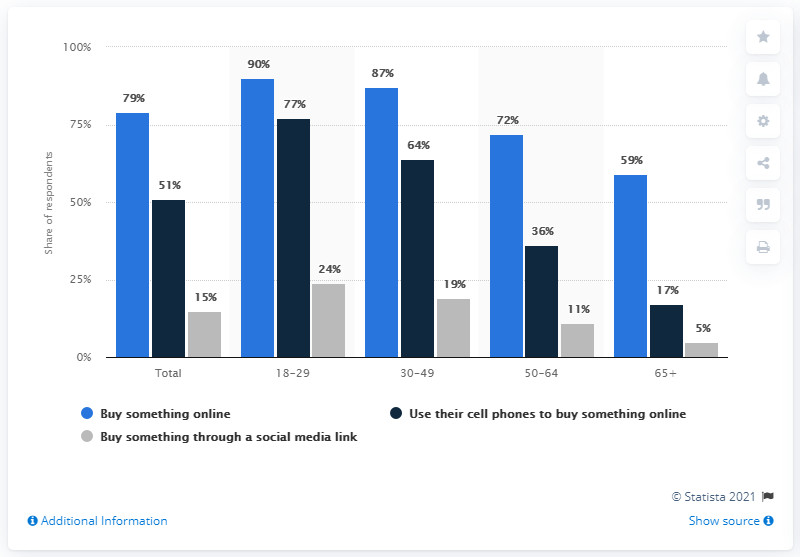Identify some key points in this picture. There is a significant difference in the experience of buying something online through a social media link compared to using a cell phone to buy something online, regardless of age group. The color bar that is always the tallest is light blue. 